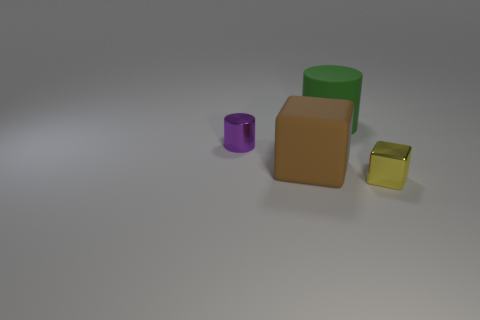Add 3 tiny purple metal cylinders. How many objects exist? 7 Subtract all brown blocks. Subtract all purple metal cylinders. How many objects are left? 2 Add 2 big green cylinders. How many big green cylinders are left? 3 Add 4 big brown rubber balls. How many big brown rubber balls exist? 4 Subtract 0 blue cylinders. How many objects are left? 4 Subtract 1 blocks. How many blocks are left? 1 Subtract all gray blocks. Subtract all cyan cylinders. How many blocks are left? 2 Subtract all brown cubes. How many blue cylinders are left? 0 